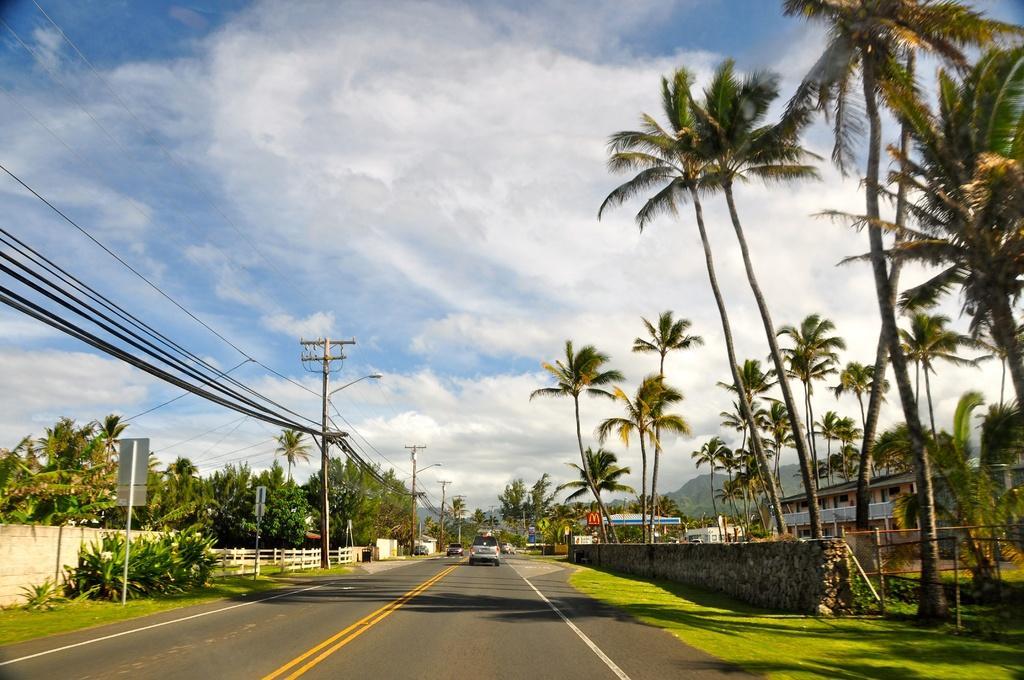How would you summarize this image in a sentence or two? In the center of the image there is a road and we can see cars on the road. In the background there are trees, building, fence, wires and sky. 